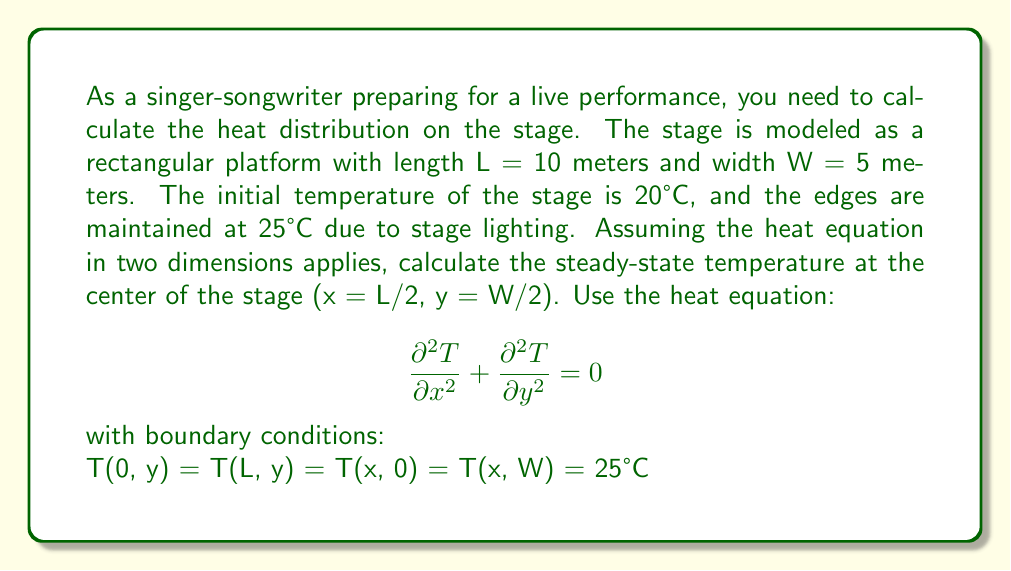Solve this math problem. To solve this problem, we'll use the method of separation of variables for the 2D heat equation.

Step 1: Assume the solution has the form T(x,y) = X(x)Y(y)

Step 2: Substituting into the heat equation:
$$X''(x)Y(y) + X(x)Y''(y) = 0$$
$$\frac{X''(x)}{X(x)} = -\frac{Y''(y)}{Y(y)} = -\lambda^2$$

Step 3: Solve the resulting ODEs:
$$X(x) = A \cos(\lambda x) + B \sin(\lambda x)$$
$$Y(y) = C \cos(\lambda y) + D \sin(\lambda y)$$

Step 4: Apply boundary conditions:
T(0, y) = T(L, y) = 25°C implies $\lambda_n = \frac{n\pi}{L}$, where n is odd.
T(x, 0) = T(x, W) = 25°C implies $\lambda_m = \frac{m\pi}{W}$, where m is odd.

Step 5: The general solution is:
$$T(x,y) = 25 + \sum_{n=1,3,5...}^\infty \sum_{m=1,3,5...}^\infty a_{nm} \sin(\frac{n\pi x}{L}) \sin(\frac{m\pi y}{W})$$

Step 6: The coefficients $a_{nm}$ are found using the initial condition:
$$a_{nm} = \frac{4}{LW} \int_0^L \int_0^W (20 - 25) \sin(\frac{n\pi x}{L}) \sin(\frac{m\pi y}{W}) dx dy$$
$$a_{nm} = -\frac{16}{nm\pi^2} \text{ for n, m odd}$$

Step 7: The temperature at the center (x = L/2, y = W/2) is:
$$T(\frac{L}{2}, \frac{W}{2}) = 25 + \sum_{n,m=1,3,5...}^\infty -\frac{16}{nm\pi^2} \sin(\frac{n\pi}{2}) \sin(\frac{m\pi}{2})$$

Step 8: Evaluate the series numerically (e.g., using a computer or calculator) to get the final answer.
Answer: $$T(\frac{L}{2}, \frac{W}{2}) \approx 22.5°C$$ 